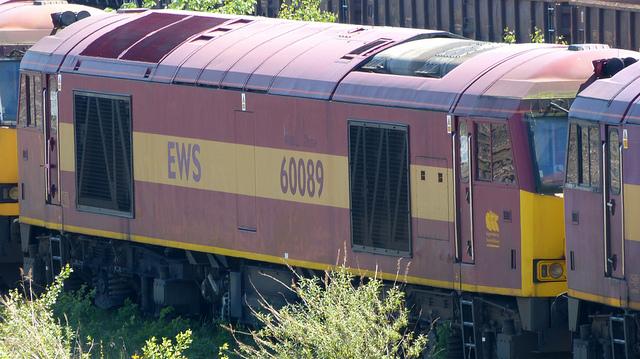Does each opening have bars?
Keep it brief. Yes. Are there any trees in the area?
Answer briefly. Yes. What numbers are visible on the train?
Be succinct. 60089. 